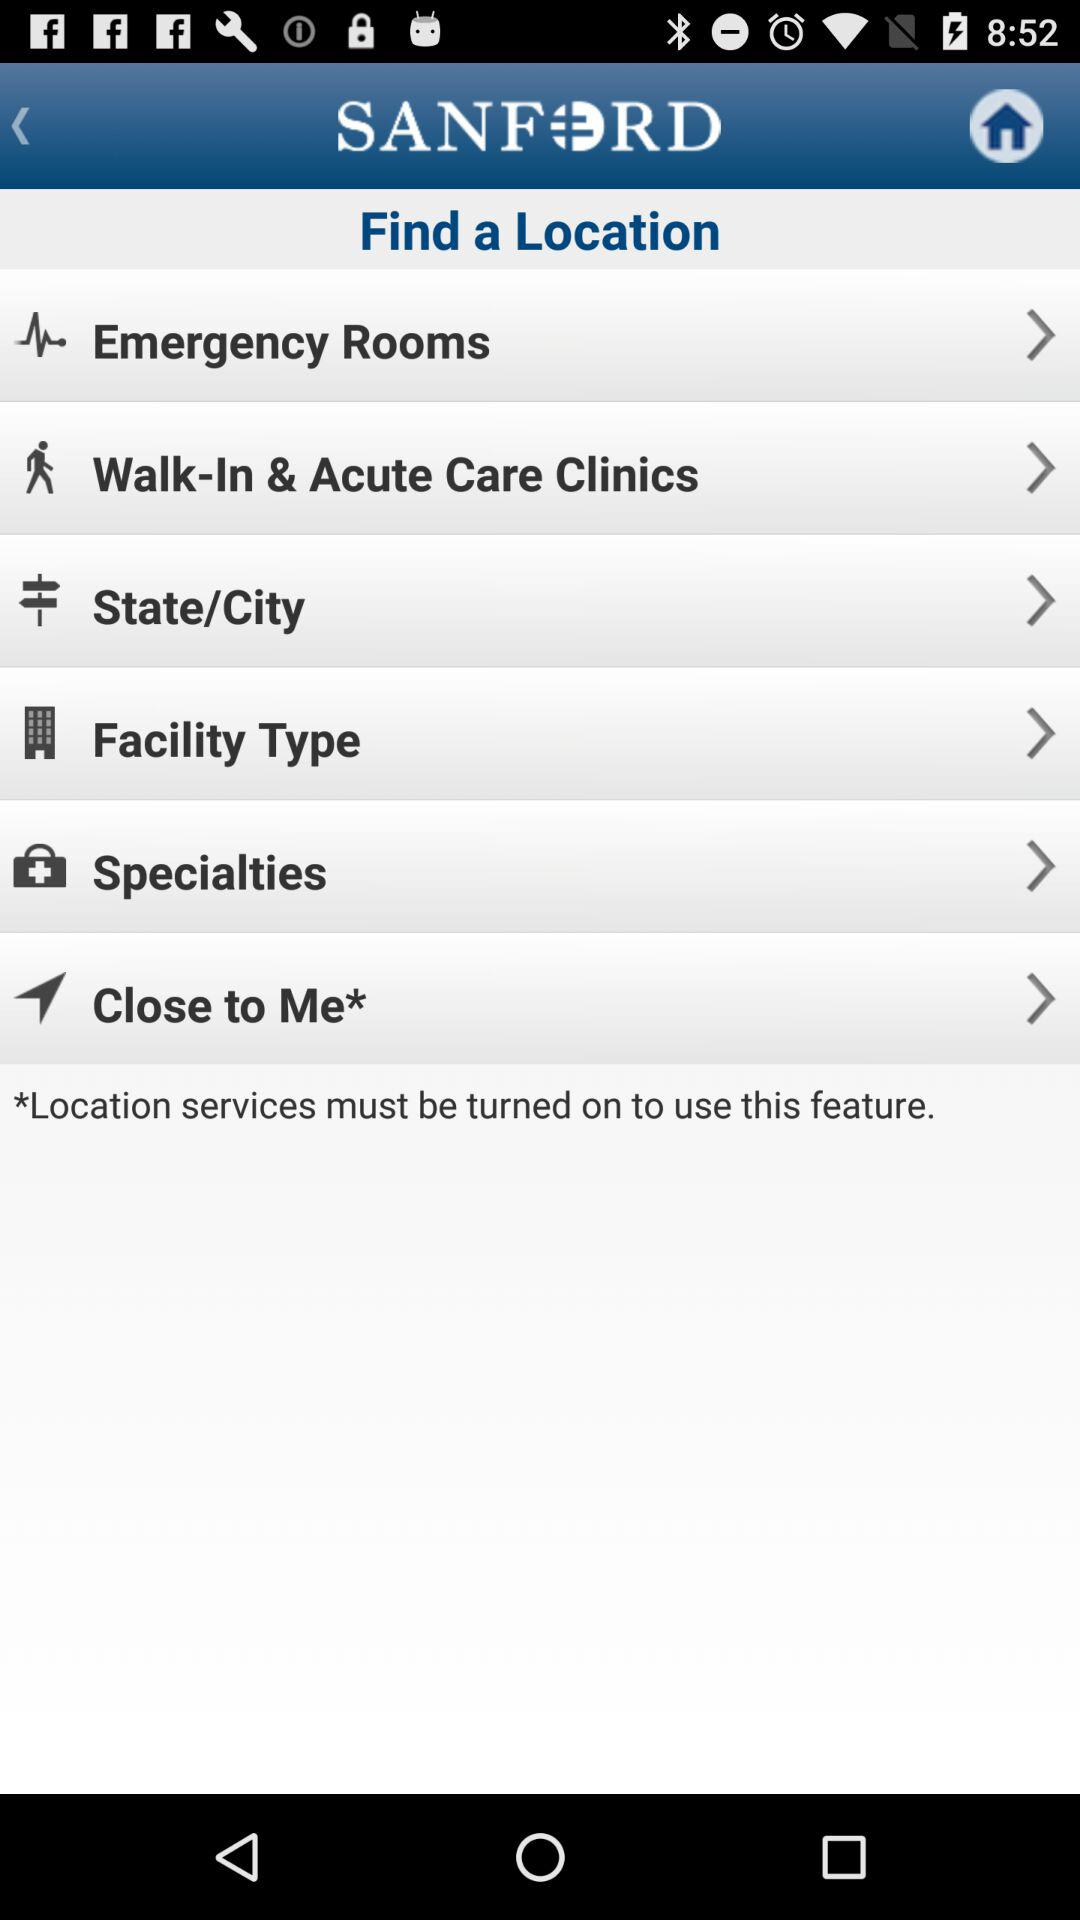What services must be turned on to use the feature? To use the feature, "Location" services must be turned on. 